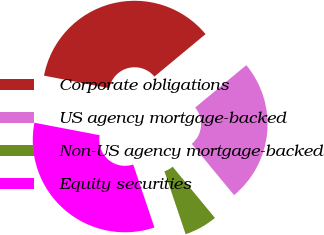Convert chart. <chart><loc_0><loc_0><loc_500><loc_500><pie_chart><fcel>Corporate obligations<fcel>US agency mortgage-backed<fcel>Non-US agency mortgage-backed<fcel>Equity securities<nl><fcel>35.97%<fcel>25.03%<fcel>5.82%<fcel>33.18%<nl></chart> 